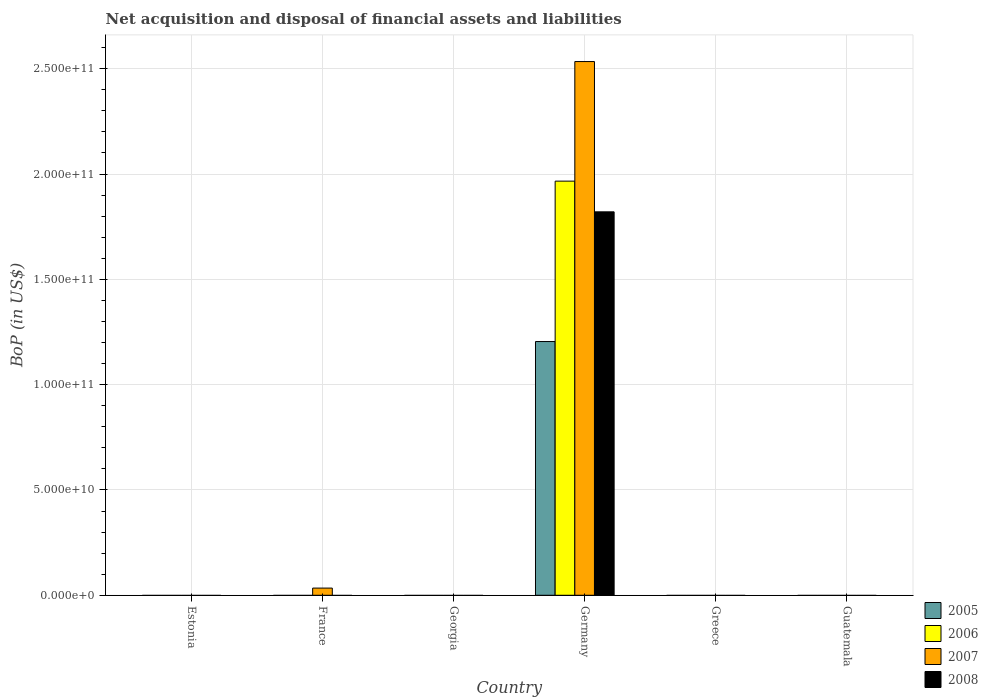How many different coloured bars are there?
Give a very brief answer. 4. Are the number of bars per tick equal to the number of legend labels?
Offer a terse response. No. What is the label of the 6th group of bars from the left?
Keep it short and to the point. Guatemala. In how many cases, is the number of bars for a given country not equal to the number of legend labels?
Provide a succinct answer. 5. Across all countries, what is the maximum Balance of Payments in 2007?
Your answer should be very brief. 2.53e+11. What is the total Balance of Payments in 2007 in the graph?
Provide a short and direct response. 2.57e+11. What is the difference between the Balance of Payments in 2007 in Guatemala and the Balance of Payments in 2005 in Georgia?
Ensure brevity in your answer.  0. What is the average Balance of Payments in 2006 per country?
Provide a short and direct response. 3.28e+1. What is the difference between the Balance of Payments of/in 2005 and Balance of Payments of/in 2006 in Germany?
Make the answer very short. -7.62e+1. In how many countries, is the Balance of Payments in 2007 greater than 190000000000 US$?
Your response must be concise. 1. What is the difference between the highest and the lowest Balance of Payments in 2005?
Make the answer very short. 1.20e+11. In how many countries, is the Balance of Payments in 2007 greater than the average Balance of Payments in 2007 taken over all countries?
Provide a short and direct response. 1. Is it the case that in every country, the sum of the Balance of Payments in 2005 and Balance of Payments in 2007 is greater than the Balance of Payments in 2008?
Keep it short and to the point. No. How many bars are there?
Ensure brevity in your answer.  5. How many countries are there in the graph?
Your response must be concise. 6. What is the difference between two consecutive major ticks on the Y-axis?
Your response must be concise. 5.00e+1. Are the values on the major ticks of Y-axis written in scientific E-notation?
Offer a very short reply. Yes. Does the graph contain any zero values?
Your answer should be compact. Yes. Where does the legend appear in the graph?
Your answer should be compact. Bottom right. How many legend labels are there?
Your answer should be very brief. 4. How are the legend labels stacked?
Your response must be concise. Vertical. What is the title of the graph?
Your answer should be compact. Net acquisition and disposal of financial assets and liabilities. Does "1998" appear as one of the legend labels in the graph?
Ensure brevity in your answer.  No. What is the label or title of the Y-axis?
Offer a very short reply. BoP (in US$). What is the BoP (in US$) of 2006 in Estonia?
Ensure brevity in your answer.  0. What is the BoP (in US$) in 2007 in Estonia?
Offer a terse response. 0. What is the BoP (in US$) in 2008 in Estonia?
Offer a very short reply. 0. What is the BoP (in US$) of 2006 in France?
Your answer should be very brief. 0. What is the BoP (in US$) of 2007 in France?
Ensure brevity in your answer.  3.41e+09. What is the BoP (in US$) in 2005 in Georgia?
Offer a terse response. 0. What is the BoP (in US$) of 2006 in Georgia?
Provide a short and direct response. 0. What is the BoP (in US$) of 2007 in Georgia?
Make the answer very short. 0. What is the BoP (in US$) of 2008 in Georgia?
Give a very brief answer. 0. What is the BoP (in US$) in 2005 in Germany?
Your answer should be very brief. 1.20e+11. What is the BoP (in US$) of 2006 in Germany?
Offer a very short reply. 1.97e+11. What is the BoP (in US$) of 2007 in Germany?
Provide a short and direct response. 2.53e+11. What is the BoP (in US$) in 2008 in Germany?
Make the answer very short. 1.82e+11. What is the BoP (in US$) in 2006 in Greece?
Ensure brevity in your answer.  0. What is the BoP (in US$) of 2007 in Greece?
Provide a short and direct response. 0. What is the BoP (in US$) in 2008 in Greece?
Offer a terse response. 0. What is the BoP (in US$) in 2005 in Guatemala?
Provide a short and direct response. 0. What is the BoP (in US$) in 2007 in Guatemala?
Your response must be concise. 0. Across all countries, what is the maximum BoP (in US$) of 2005?
Offer a terse response. 1.20e+11. Across all countries, what is the maximum BoP (in US$) in 2006?
Provide a short and direct response. 1.97e+11. Across all countries, what is the maximum BoP (in US$) in 2007?
Provide a short and direct response. 2.53e+11. Across all countries, what is the maximum BoP (in US$) of 2008?
Ensure brevity in your answer.  1.82e+11. Across all countries, what is the minimum BoP (in US$) of 2005?
Provide a succinct answer. 0. Across all countries, what is the minimum BoP (in US$) of 2006?
Your answer should be compact. 0. Across all countries, what is the minimum BoP (in US$) in 2007?
Give a very brief answer. 0. What is the total BoP (in US$) in 2005 in the graph?
Your response must be concise. 1.20e+11. What is the total BoP (in US$) of 2006 in the graph?
Your answer should be very brief. 1.97e+11. What is the total BoP (in US$) in 2007 in the graph?
Offer a terse response. 2.57e+11. What is the total BoP (in US$) of 2008 in the graph?
Offer a very short reply. 1.82e+11. What is the difference between the BoP (in US$) in 2007 in France and that in Germany?
Your answer should be compact. -2.50e+11. What is the difference between the BoP (in US$) of 2007 in France and the BoP (in US$) of 2008 in Germany?
Provide a short and direct response. -1.79e+11. What is the average BoP (in US$) of 2005 per country?
Offer a terse response. 2.01e+1. What is the average BoP (in US$) in 2006 per country?
Give a very brief answer. 3.28e+1. What is the average BoP (in US$) of 2007 per country?
Provide a succinct answer. 4.28e+1. What is the average BoP (in US$) in 2008 per country?
Provide a succinct answer. 3.03e+1. What is the difference between the BoP (in US$) in 2005 and BoP (in US$) in 2006 in Germany?
Your answer should be compact. -7.62e+1. What is the difference between the BoP (in US$) of 2005 and BoP (in US$) of 2007 in Germany?
Make the answer very short. -1.33e+11. What is the difference between the BoP (in US$) of 2005 and BoP (in US$) of 2008 in Germany?
Make the answer very short. -6.16e+1. What is the difference between the BoP (in US$) of 2006 and BoP (in US$) of 2007 in Germany?
Your answer should be very brief. -5.68e+1. What is the difference between the BoP (in US$) in 2006 and BoP (in US$) in 2008 in Germany?
Provide a short and direct response. 1.46e+1. What is the difference between the BoP (in US$) of 2007 and BoP (in US$) of 2008 in Germany?
Your answer should be compact. 7.13e+1. What is the ratio of the BoP (in US$) of 2007 in France to that in Germany?
Offer a very short reply. 0.01. What is the difference between the highest and the lowest BoP (in US$) in 2005?
Give a very brief answer. 1.20e+11. What is the difference between the highest and the lowest BoP (in US$) in 2006?
Your answer should be compact. 1.97e+11. What is the difference between the highest and the lowest BoP (in US$) in 2007?
Provide a succinct answer. 2.53e+11. What is the difference between the highest and the lowest BoP (in US$) of 2008?
Your answer should be compact. 1.82e+11. 